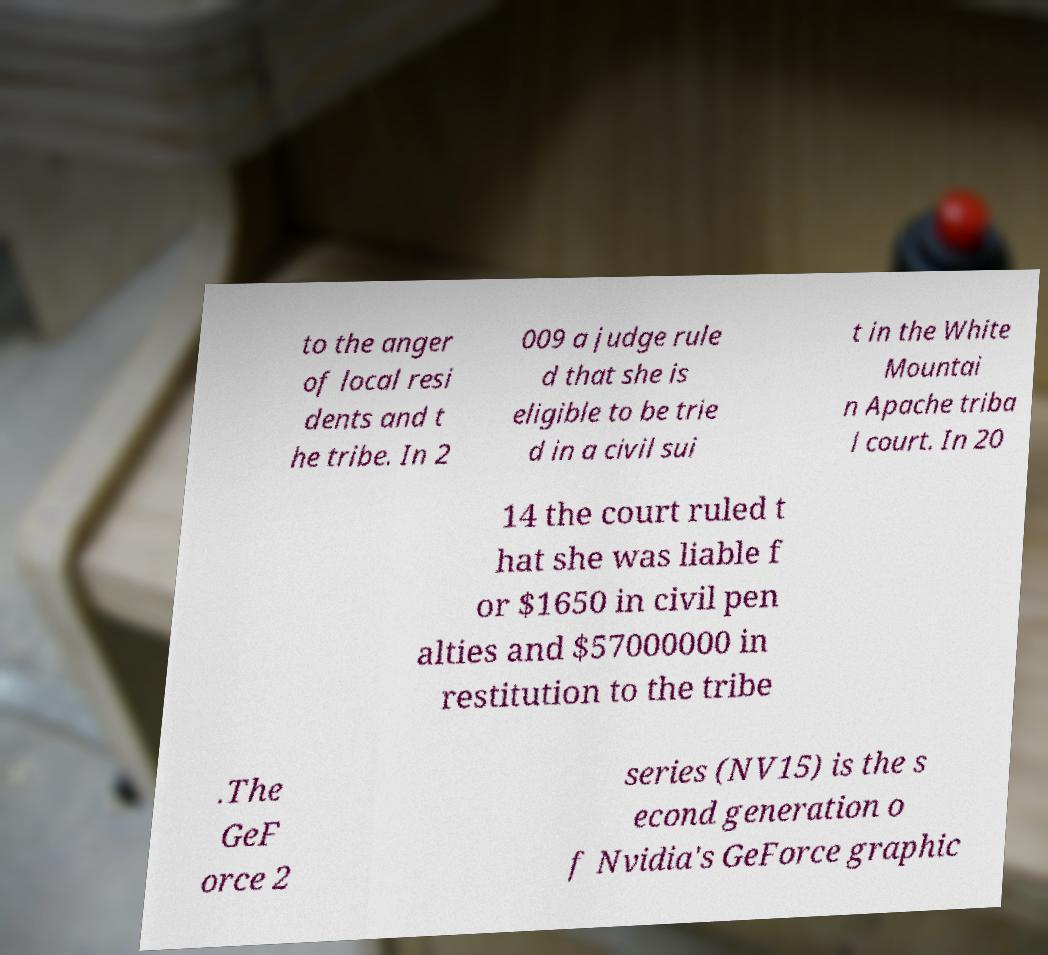I need the written content from this picture converted into text. Can you do that? to the anger of local resi dents and t he tribe. In 2 009 a judge rule d that she is eligible to be trie d in a civil sui t in the White Mountai n Apache triba l court. In 20 14 the court ruled t hat she was liable f or $1650 in civil pen alties and $57000000 in restitution to the tribe .The GeF orce 2 series (NV15) is the s econd generation o f Nvidia's GeForce graphic 